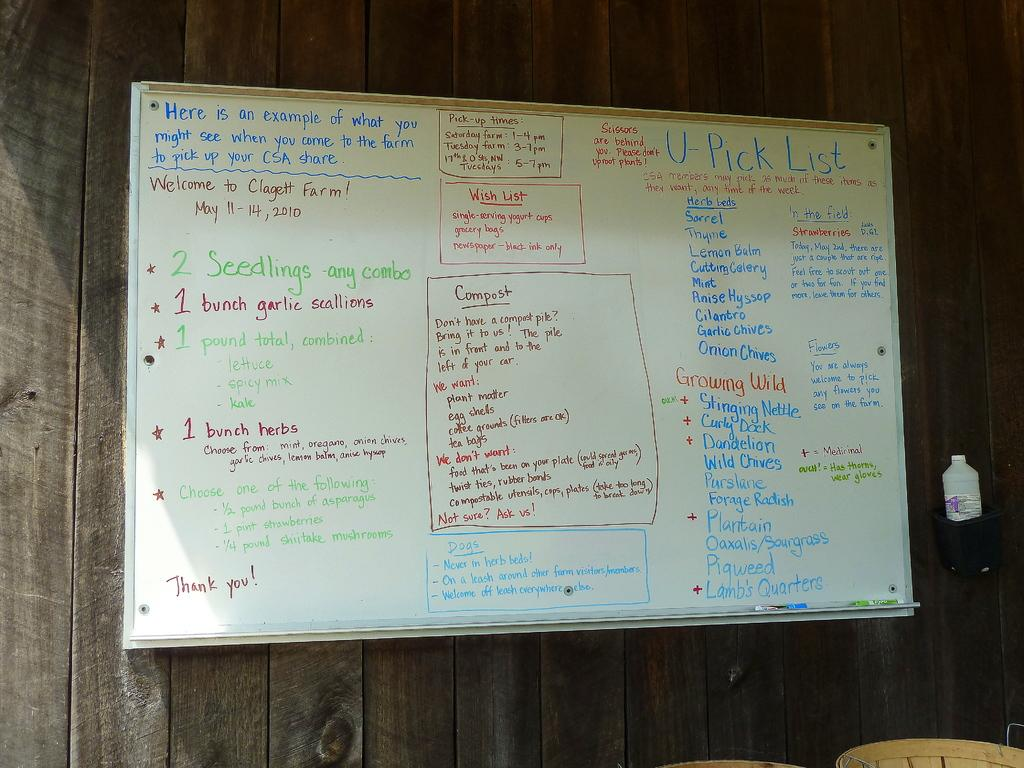<image>
Summarize the visual content of the image. A U-Pick List on a whiteboard along with several detailed instructions. 